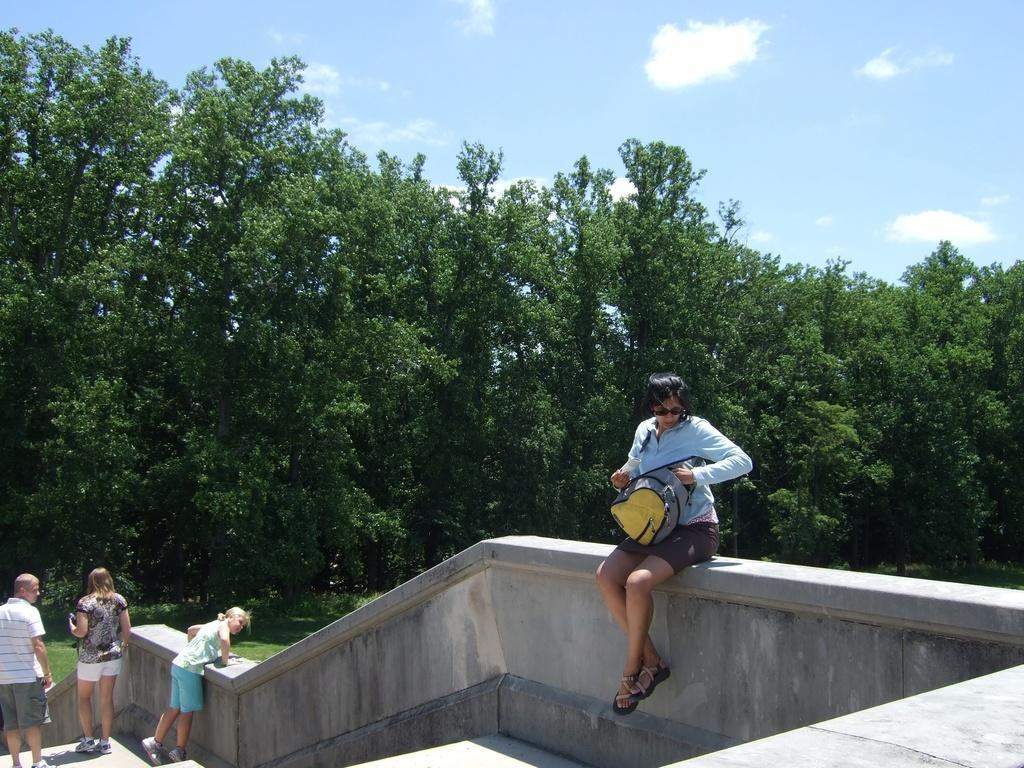Describe this image in one or two sentences. In this image we can see a person with goggles, holding a bag and sitting on the wall, there we can see a few people on the steps, there we can also see few trees, grass and some clouds in the sky. 